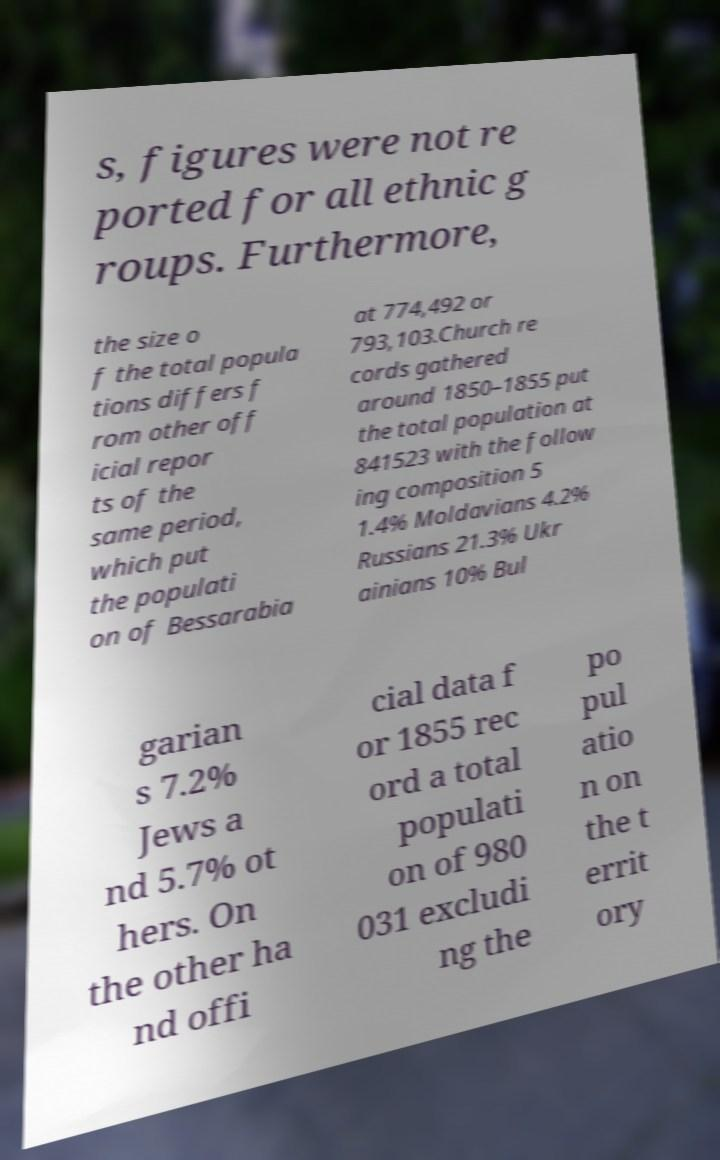There's text embedded in this image that I need extracted. Can you transcribe it verbatim? s, figures were not re ported for all ethnic g roups. Furthermore, the size o f the total popula tions differs f rom other off icial repor ts of the same period, which put the populati on of Bessarabia at 774,492 or 793,103.Church re cords gathered around 1850–1855 put the total population at 841523 with the follow ing composition 5 1.4% Moldavians 4.2% Russians 21.3% Ukr ainians 10% Bul garian s 7.2% Jews a nd 5.7% ot hers. On the other ha nd offi cial data f or 1855 rec ord a total populati on of 980 031 excludi ng the po pul atio n on the t errit ory 